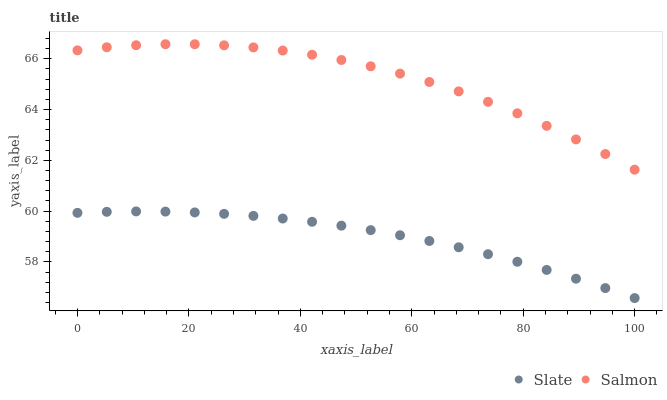Does Slate have the minimum area under the curve?
Answer yes or no. Yes. Does Salmon have the maximum area under the curve?
Answer yes or no. Yes. Does Salmon have the minimum area under the curve?
Answer yes or no. No. Is Slate the smoothest?
Answer yes or no. Yes. Is Salmon the roughest?
Answer yes or no. Yes. Is Salmon the smoothest?
Answer yes or no. No. Does Slate have the lowest value?
Answer yes or no. Yes. Does Salmon have the lowest value?
Answer yes or no. No. Does Salmon have the highest value?
Answer yes or no. Yes. Is Slate less than Salmon?
Answer yes or no. Yes. Is Salmon greater than Slate?
Answer yes or no. Yes. Does Slate intersect Salmon?
Answer yes or no. No. 